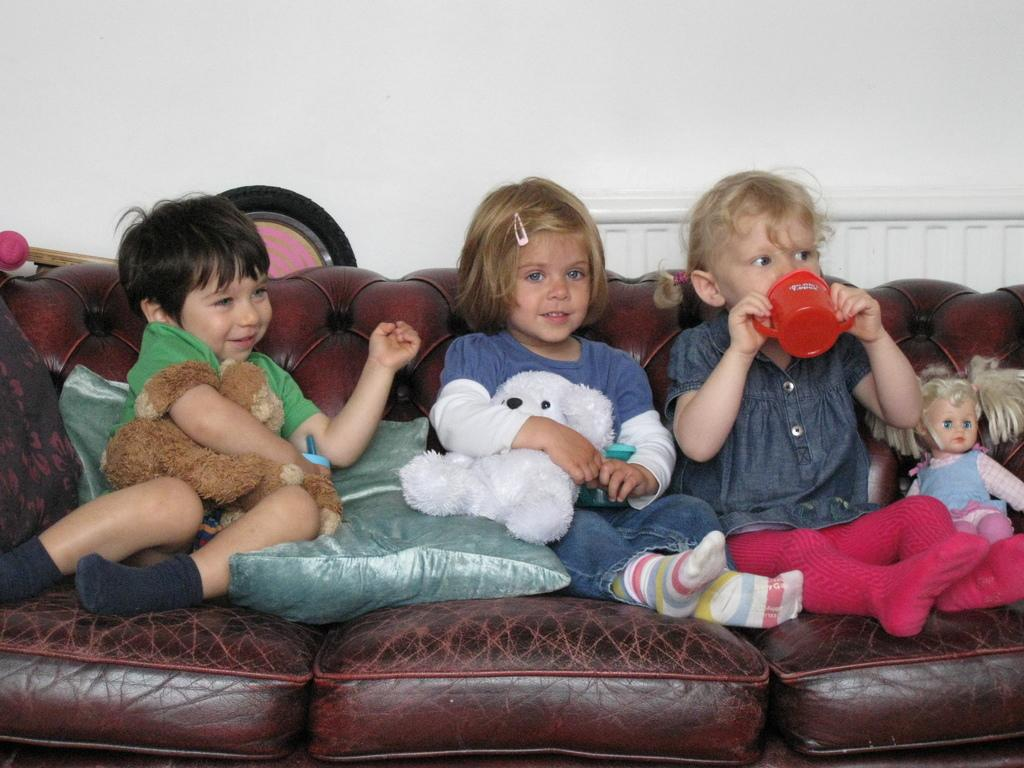How many girls are present in the image? There are two girls in the image. What are the girls holding in the image? One girl is holding a baby doll, and the other girl is holding a doll. Where are the girls sitting in the image? Both girls are sitting on a sofa. What can be seen behind the girls in the image? There is a wall visible behind them. What type of yam can be smelled in the image? There is no yam present in the image, and therefore no scent can be associated with it. 